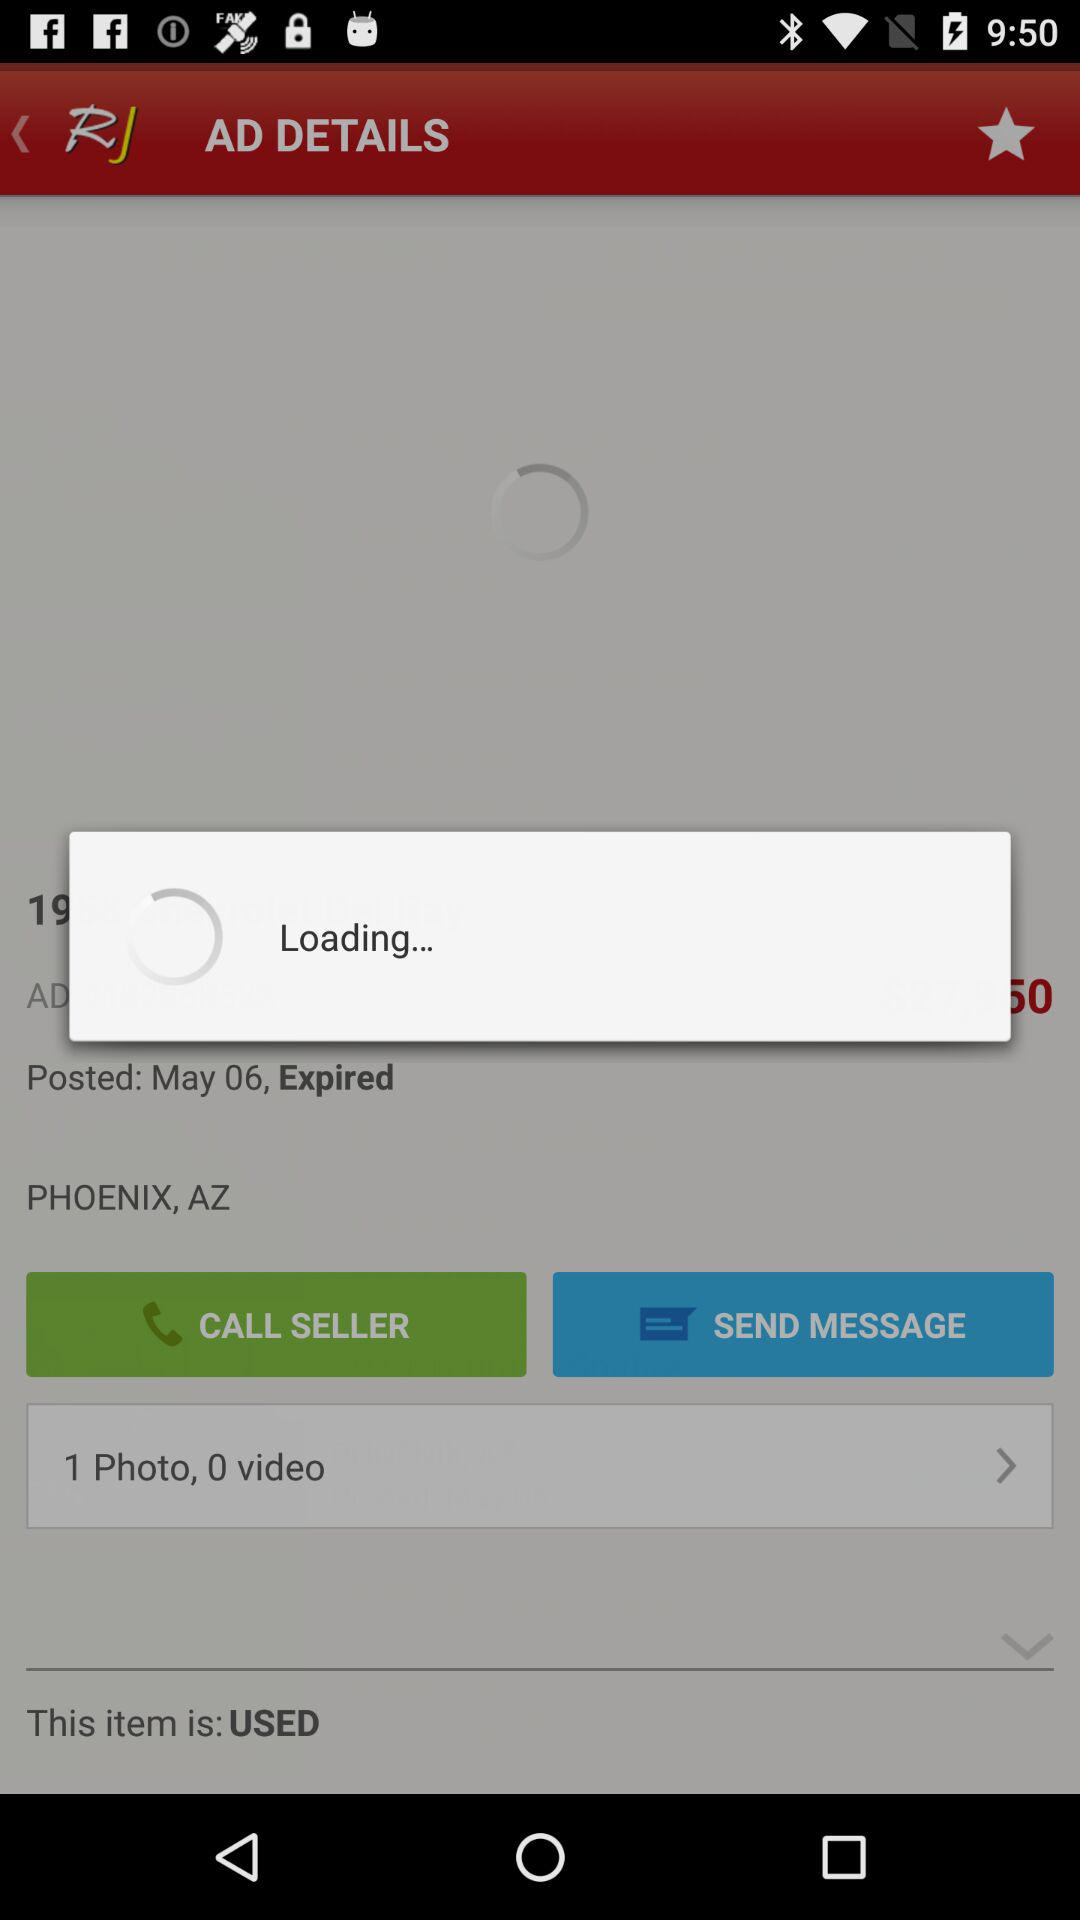On what date was the advertisement posted? The advertisement was posted on May 6. 